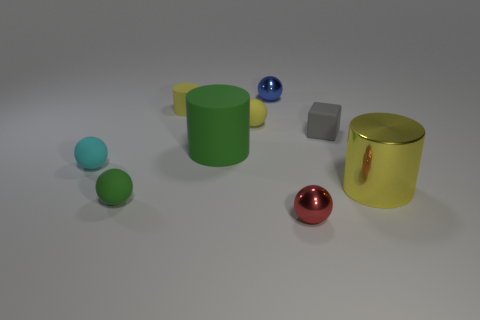Subtract all small cyan spheres. How many spheres are left? 4 Subtract all gray spheres. How many yellow cylinders are left? 2 Subtract all yellow cylinders. How many cylinders are left? 1 Subtract 1 cylinders. How many cylinders are left? 2 Add 1 small gray matte cylinders. How many objects exist? 10 Subtract all cubes. How many objects are left? 8 Add 8 small blue objects. How many small blue objects are left? 9 Add 5 small spheres. How many small spheres exist? 10 Subtract 0 red cylinders. How many objects are left? 9 Subtract all yellow blocks. Subtract all yellow cylinders. How many blocks are left? 1 